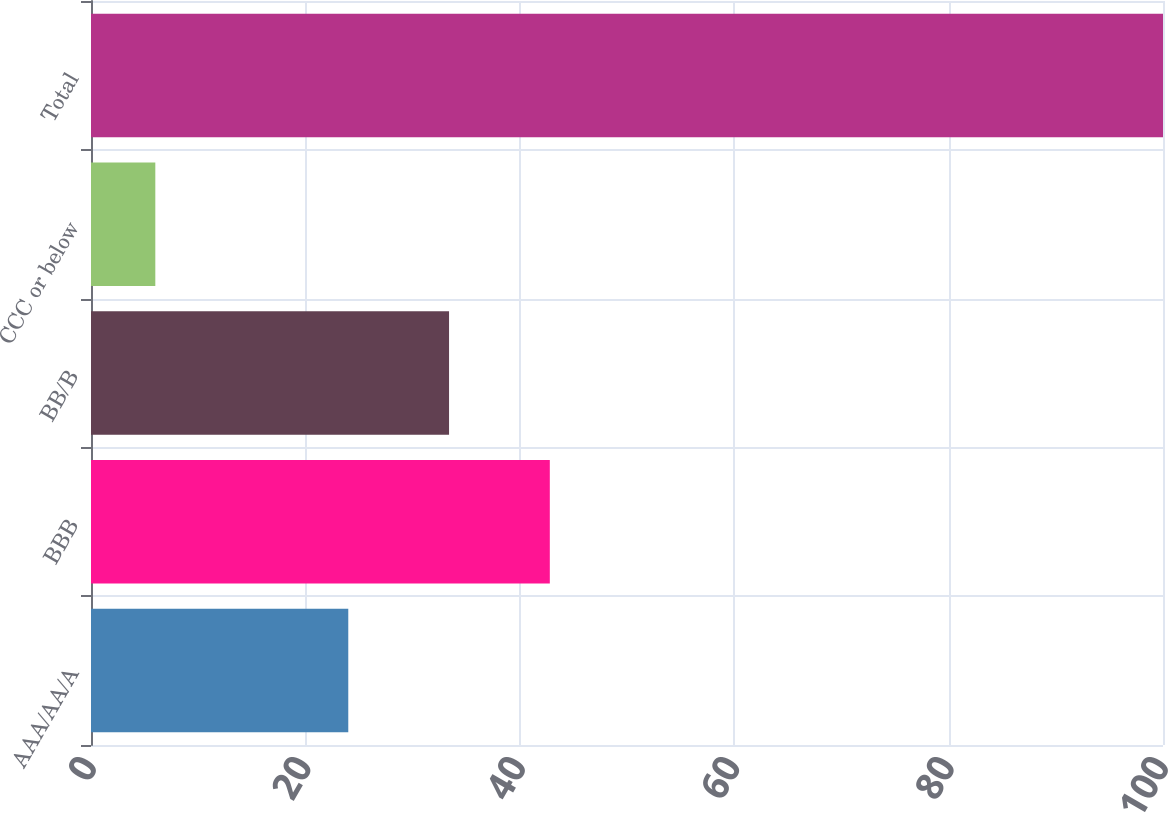Convert chart to OTSL. <chart><loc_0><loc_0><loc_500><loc_500><bar_chart><fcel>AAA/AA/A<fcel>BBB<fcel>BB/B<fcel>CCC or below<fcel>Total<nl><fcel>24<fcel>42.8<fcel>33.4<fcel>6<fcel>100<nl></chart> 